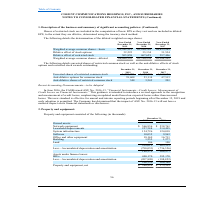From Cogent Communications Group's financial document, What are the respective values of network equipment in 2018 and 2019? The document shows two values: $538,761 and $566,936 (in thousands). From the document: "2018 Owned assets: Network equipment $ 566,936 $ 538,761 Leasehold improvements 227,388 214,495 System infrastructure 134,726 124,018 Software 10,035 ..." Also, What are the respective values of leasehold improvements in 2018 and 2019? The document shows two values: 214,495 and 227,388 (in thousands). From the document: "566,936 $ 538,761 Leasehold improvements 227,388 214,495 System infrastructure 134,726 124,018 Software 10,035 9,963 Office and other equipment 18,169..." Also, What are the respective values of system infrastructure in 2018 and 2019? The document shows two values: 124,018 and 134,726 (in thousands). From the document: "mprovements 227,388 214,495 System infrastructure 134,726 124,018 Software 10,035 9,963 Office and other equipment 18,169 16,711 Building 1,252 1,277 ..." Also, can you calculate: What is the percentage change in the value of network equipment between 2018 and 2019? To answer this question, I need to perform calculations using the financial data. The calculation is: (566,936 - 538,761)/538,761 , which equals 5.23 (percentage). This is based on the information: "2018 Owned assets: Network equipment $ 566,936 $ 538,761 Leasehold improvements 227,388 214,495 System infrastructure 134,726 124,018 Software 10,035 9,963 r 31, 2019 2018 Owned assets: Network equipm..." The key data points involved are: 538,761, 566,936. Also, can you calculate: What is the percentage change in the value of leasehold improvements between 2018 and 2019? To answer this question, I need to perform calculations using the financial data. The calculation is: (227,388 - 214,495)/214,495 , which equals 6.01 (percentage). This is based on the information: "566,936 $ 538,761 Leasehold improvements 227,388 214,495 System infrastructure 134,726 124,018 Software 10,035 9,963 Office and other equipment 18,169 16,71 ipment $ 566,936 $ 538,761 Leasehold improv..." The key data points involved are: 214,495, 227,388. Also, can you calculate: What is the percentage change in the value of system infrastructure between 2018 and 2019? To answer this question, I need to perform calculations using the financial data. The calculation is: (134,726 - 124,018 )/124,018  , which equals 8.63 (percentage). This is based on the information: "mprovements 227,388 214,495 System infrastructure 134,726 124,018 Software 10,035 9,963 Office and other equipment 18,169 16,711 Building 1,252 1,277 Land 10 nts 227,388 214,495 System infrastructure ..." The key data points involved are: 124,018, 134,726. 